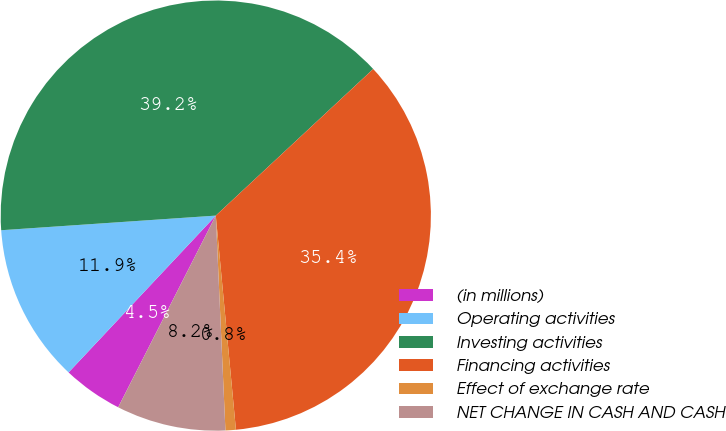<chart> <loc_0><loc_0><loc_500><loc_500><pie_chart><fcel>(in millions)<fcel>Operating activities<fcel>Investing activities<fcel>Financing activities<fcel>Effect of exchange rate<fcel>NET CHANGE IN CASH AND CASH<nl><fcel>4.5%<fcel>11.92%<fcel>39.15%<fcel>35.44%<fcel>0.78%<fcel>8.21%<nl></chart> 